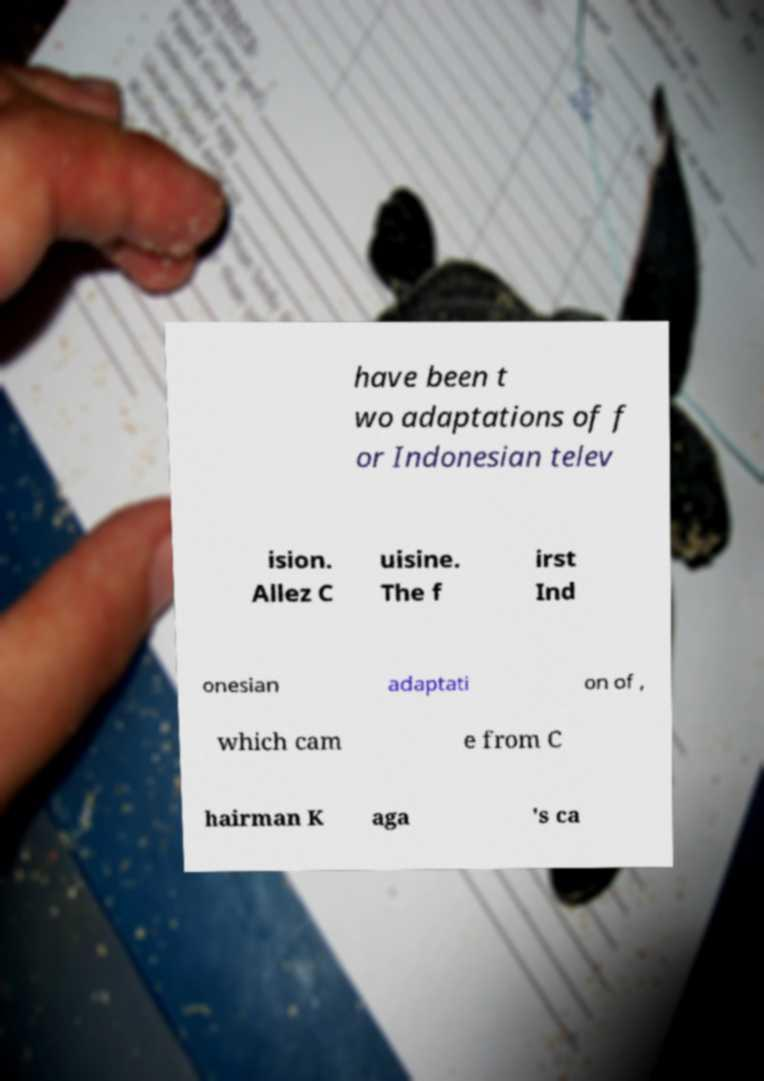Can you read and provide the text displayed in the image?This photo seems to have some interesting text. Can you extract and type it out for me? have been t wo adaptations of f or Indonesian telev ision. Allez C uisine. The f irst Ind onesian adaptati on of , which cam e from C hairman K aga 's ca 